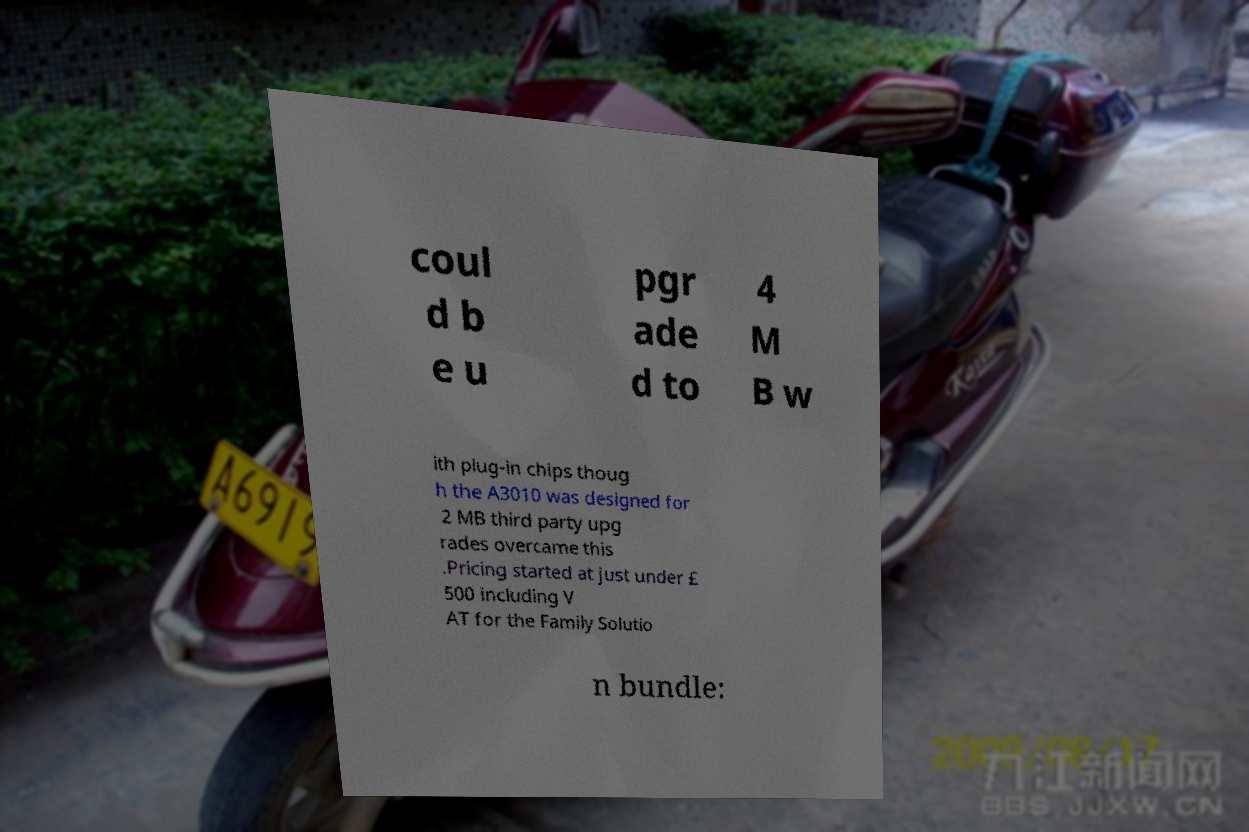For documentation purposes, I need the text within this image transcribed. Could you provide that? coul d b e u pgr ade d to 4 M B w ith plug-in chips thoug h the A3010 was designed for 2 MB third party upg rades overcame this .Pricing started at just under £ 500 including V AT for the Family Solutio n bundle: 